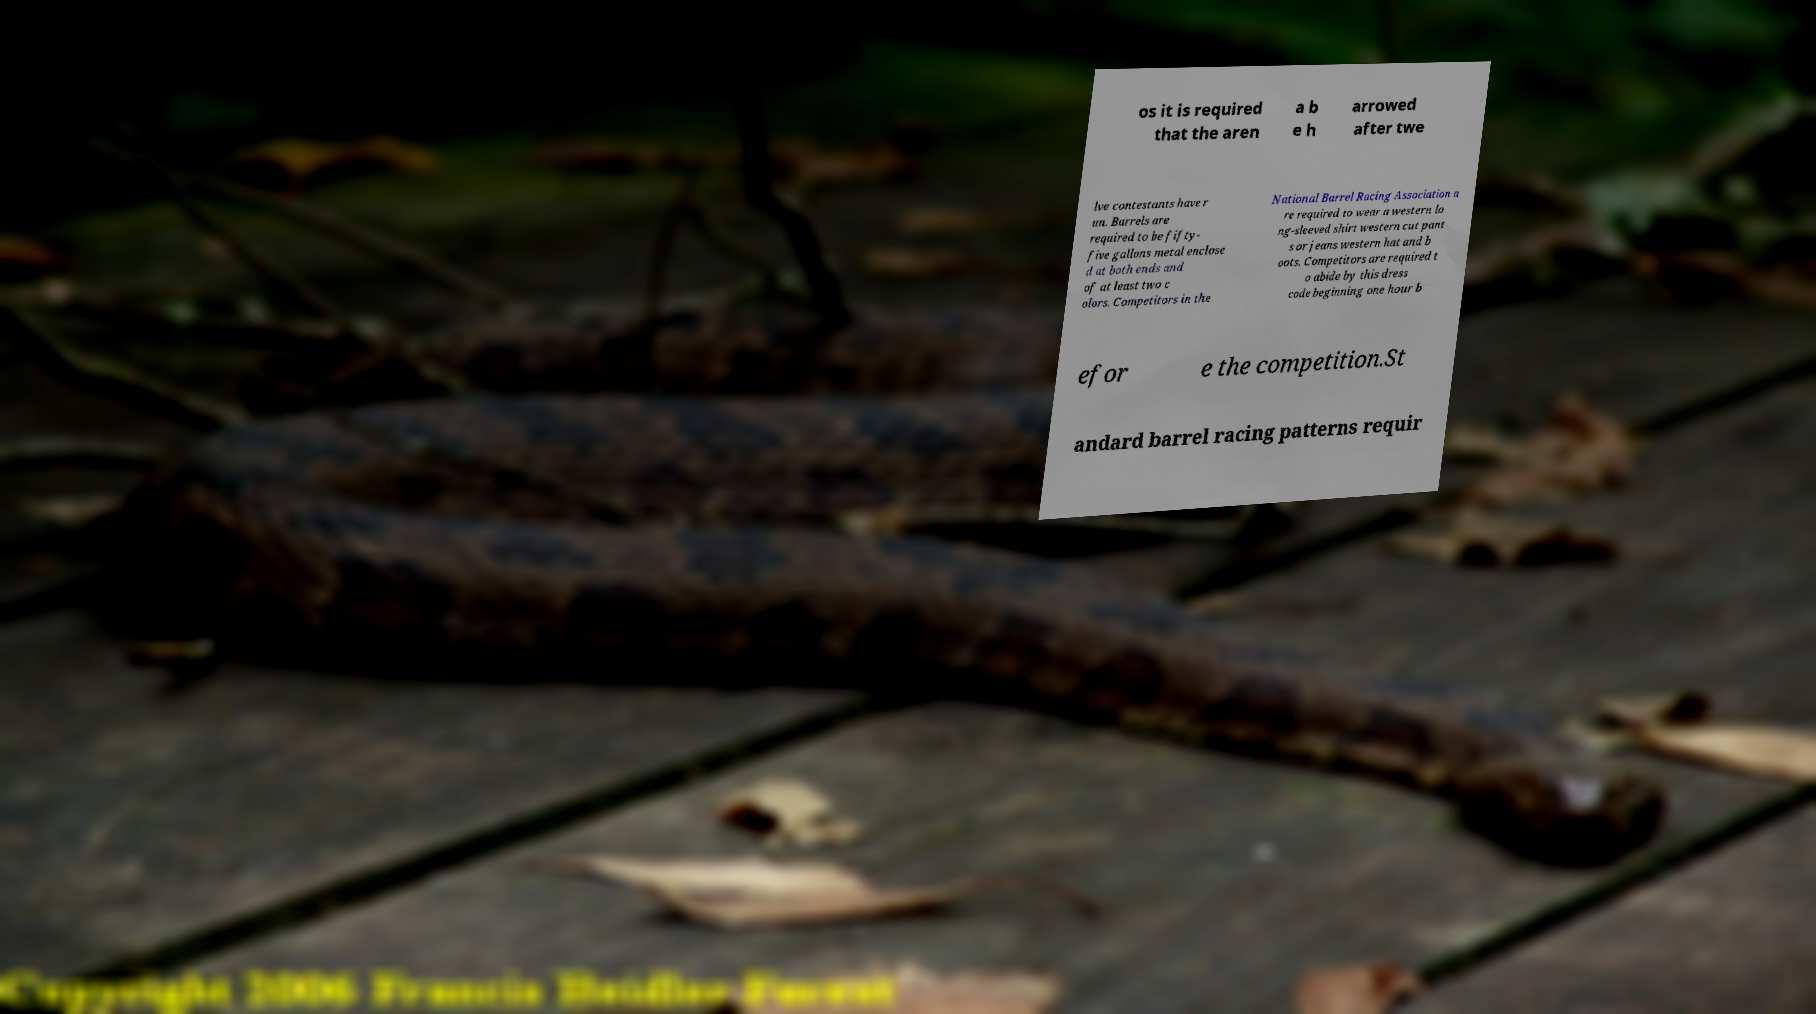Can you accurately transcribe the text from the provided image for me? os it is required that the aren a b e h arrowed after twe lve contestants have r un. Barrels are required to be fifty- five gallons metal enclose d at both ends and of at least two c olors. Competitors in the National Barrel Racing Association a re required to wear a western lo ng-sleeved shirt western cut pant s or jeans western hat and b oots. Competitors are required t o abide by this dress code beginning one hour b efor e the competition.St andard barrel racing patterns requir 